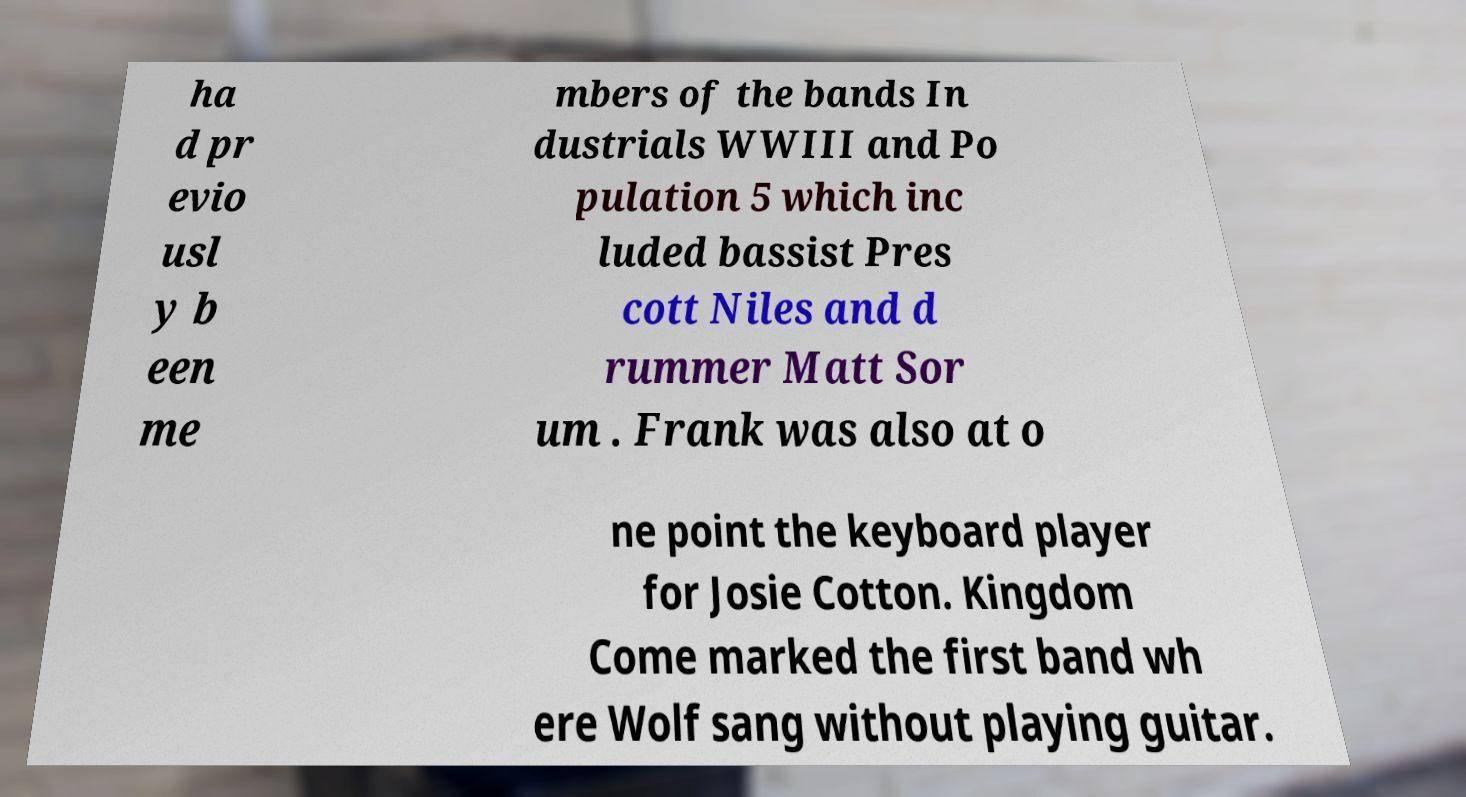Can you accurately transcribe the text from the provided image for me? ha d pr evio usl y b een me mbers of the bands In dustrials WWIII and Po pulation 5 which inc luded bassist Pres cott Niles and d rummer Matt Sor um . Frank was also at o ne point the keyboard player for Josie Cotton. Kingdom Come marked the first band wh ere Wolf sang without playing guitar. 